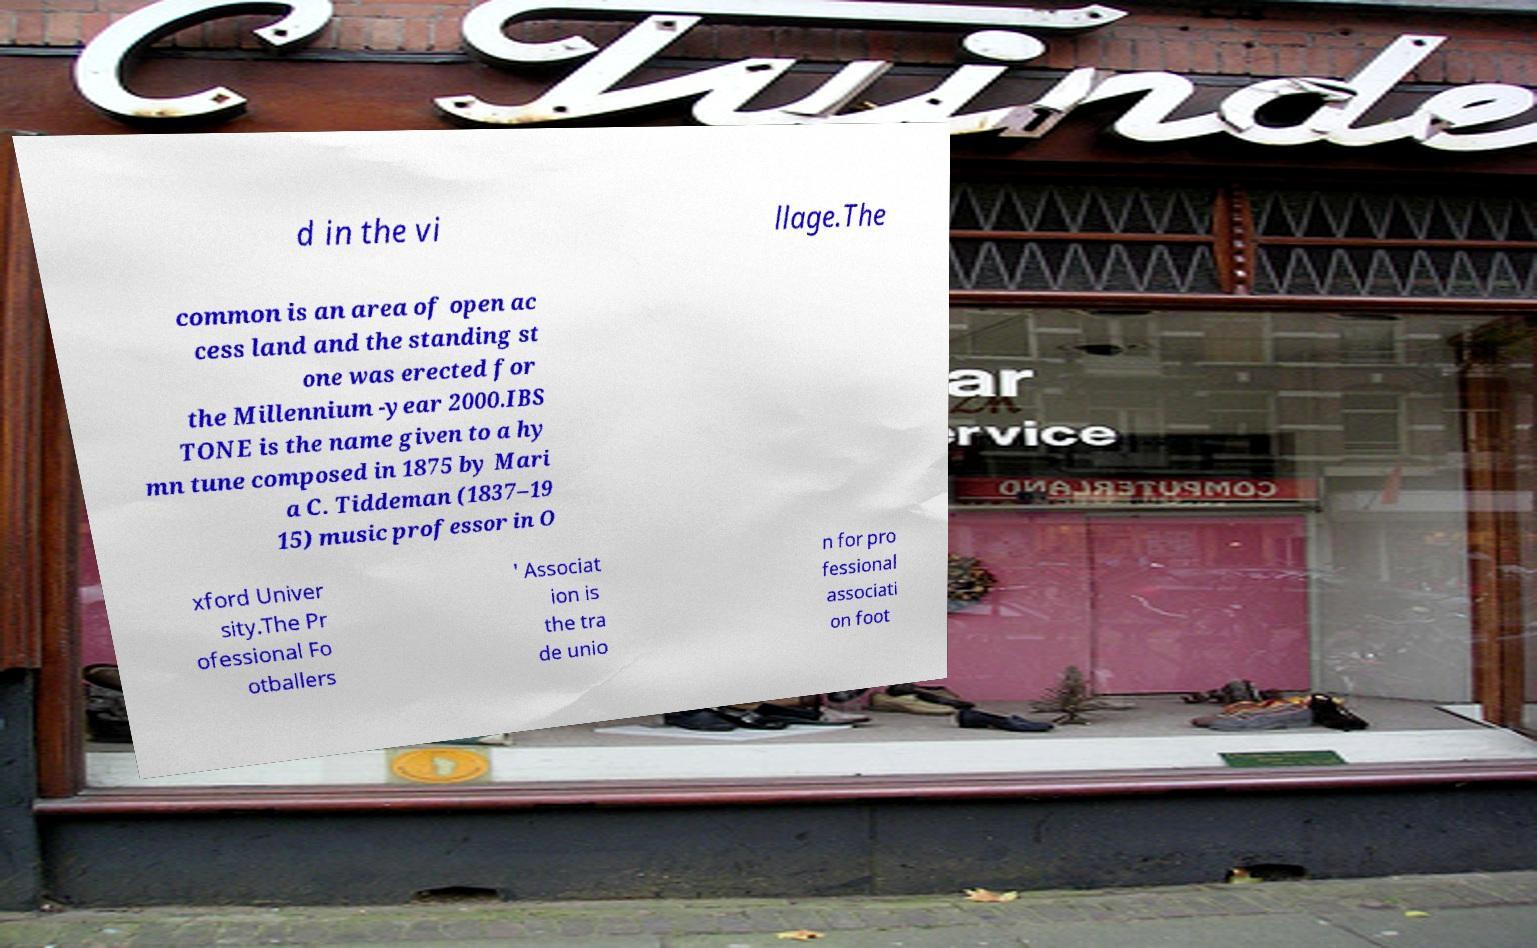I need the written content from this picture converted into text. Can you do that? d in the vi llage.The common is an area of open ac cess land and the standing st one was erected for the Millennium -year 2000.IBS TONE is the name given to a hy mn tune composed in 1875 by Mari a C. Tiddeman (1837–19 15) music professor in O xford Univer sity.The Pr ofessional Fo otballers ' Associat ion is the tra de unio n for pro fessional associati on foot 